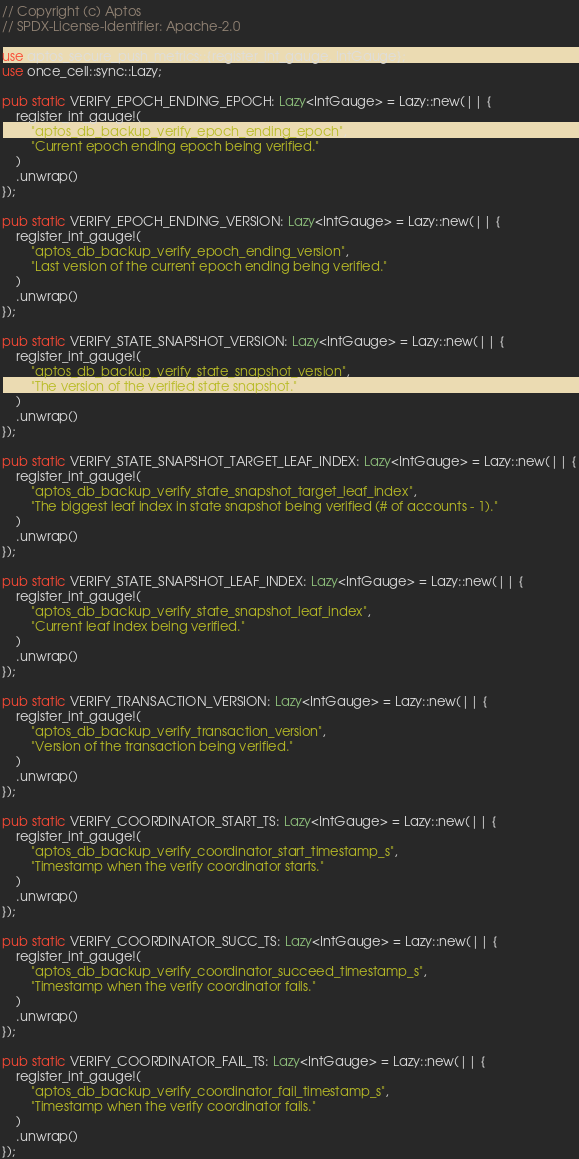Convert code to text. <code><loc_0><loc_0><loc_500><loc_500><_Rust_>// Copyright (c) Aptos
// SPDX-License-Identifier: Apache-2.0

use aptos_secure_push_metrics::{register_int_gauge, IntGauge};
use once_cell::sync::Lazy;

pub static VERIFY_EPOCH_ENDING_EPOCH: Lazy<IntGauge> = Lazy::new(|| {
    register_int_gauge!(
        "aptos_db_backup_verify_epoch_ending_epoch",
        "Current epoch ending epoch being verified."
    )
    .unwrap()
});

pub static VERIFY_EPOCH_ENDING_VERSION: Lazy<IntGauge> = Lazy::new(|| {
    register_int_gauge!(
        "aptos_db_backup_verify_epoch_ending_version",
        "Last version of the current epoch ending being verified."
    )
    .unwrap()
});

pub static VERIFY_STATE_SNAPSHOT_VERSION: Lazy<IntGauge> = Lazy::new(|| {
    register_int_gauge!(
        "aptos_db_backup_verify_state_snapshot_version",
        "The version of the verified state snapshot."
    )
    .unwrap()
});

pub static VERIFY_STATE_SNAPSHOT_TARGET_LEAF_INDEX: Lazy<IntGauge> = Lazy::new(|| {
    register_int_gauge!(
        "aptos_db_backup_verify_state_snapshot_target_leaf_index",
        "The biggest leaf index in state snapshot being verified (# of accounts - 1)."
    )
    .unwrap()
});

pub static VERIFY_STATE_SNAPSHOT_LEAF_INDEX: Lazy<IntGauge> = Lazy::new(|| {
    register_int_gauge!(
        "aptos_db_backup_verify_state_snapshot_leaf_index",
        "Current leaf index being verified."
    )
    .unwrap()
});

pub static VERIFY_TRANSACTION_VERSION: Lazy<IntGauge> = Lazy::new(|| {
    register_int_gauge!(
        "aptos_db_backup_verify_transaction_version",
        "Version of the transaction being verified."
    )
    .unwrap()
});

pub static VERIFY_COORDINATOR_START_TS: Lazy<IntGauge> = Lazy::new(|| {
    register_int_gauge!(
        "aptos_db_backup_verify_coordinator_start_timestamp_s",
        "Timestamp when the verify coordinator starts."
    )
    .unwrap()
});

pub static VERIFY_COORDINATOR_SUCC_TS: Lazy<IntGauge> = Lazy::new(|| {
    register_int_gauge!(
        "aptos_db_backup_verify_coordinator_succeed_timestamp_s",
        "Timestamp when the verify coordinator fails."
    )
    .unwrap()
});

pub static VERIFY_COORDINATOR_FAIL_TS: Lazy<IntGauge> = Lazy::new(|| {
    register_int_gauge!(
        "aptos_db_backup_verify_coordinator_fail_timestamp_s",
        "Timestamp when the verify coordinator fails."
    )
    .unwrap()
});
</code> 